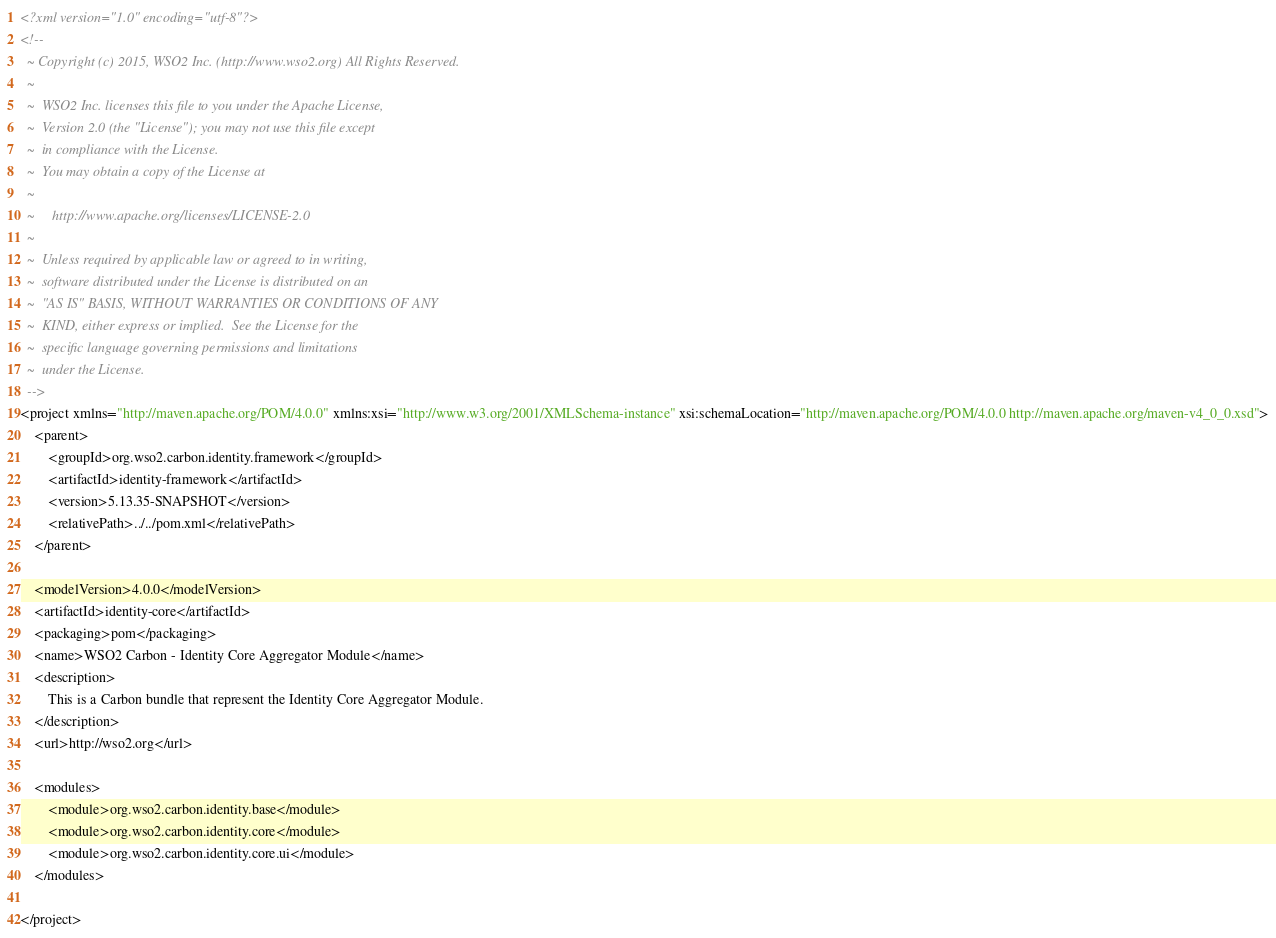Convert code to text. <code><loc_0><loc_0><loc_500><loc_500><_XML_><?xml version="1.0" encoding="utf-8"?>
<!--
  ~ Copyright (c) 2015, WSO2 Inc. (http://www.wso2.org) All Rights Reserved.
  ~
  ~  WSO2 Inc. licenses this file to you under the Apache License,
  ~  Version 2.0 (the "License"); you may not use this file except
  ~  in compliance with the License.
  ~  You may obtain a copy of the License at
  ~
  ~     http://www.apache.org/licenses/LICENSE-2.0
  ~
  ~  Unless required by applicable law or agreed to in writing,
  ~  software distributed under the License is distributed on an
  ~  "AS IS" BASIS, WITHOUT WARRANTIES OR CONDITIONS OF ANY
  ~  KIND, either express or implied.  See the License for the
  ~  specific language governing permissions and limitations
  ~  under the License.
  -->
<project xmlns="http://maven.apache.org/POM/4.0.0" xmlns:xsi="http://www.w3.org/2001/XMLSchema-instance" xsi:schemaLocation="http://maven.apache.org/POM/4.0.0 http://maven.apache.org/maven-v4_0_0.xsd">
    <parent>
        <groupId>org.wso2.carbon.identity.framework</groupId>
        <artifactId>identity-framework</artifactId>
        <version>5.13.35-SNAPSHOT</version>
        <relativePath>../../pom.xml</relativePath>
    </parent>

    <modelVersion>4.0.0</modelVersion>
    <artifactId>identity-core</artifactId>
    <packaging>pom</packaging>
    <name>WSO2 Carbon - Identity Core Aggregator Module</name>
    <description>
        This is a Carbon bundle that represent the Identity Core Aggregator Module.
    </description>
    <url>http://wso2.org</url>

    <modules>
        <module>org.wso2.carbon.identity.base</module>
        <module>org.wso2.carbon.identity.core</module>
        <module>org.wso2.carbon.identity.core.ui</module>
    </modules>

</project>
</code> 